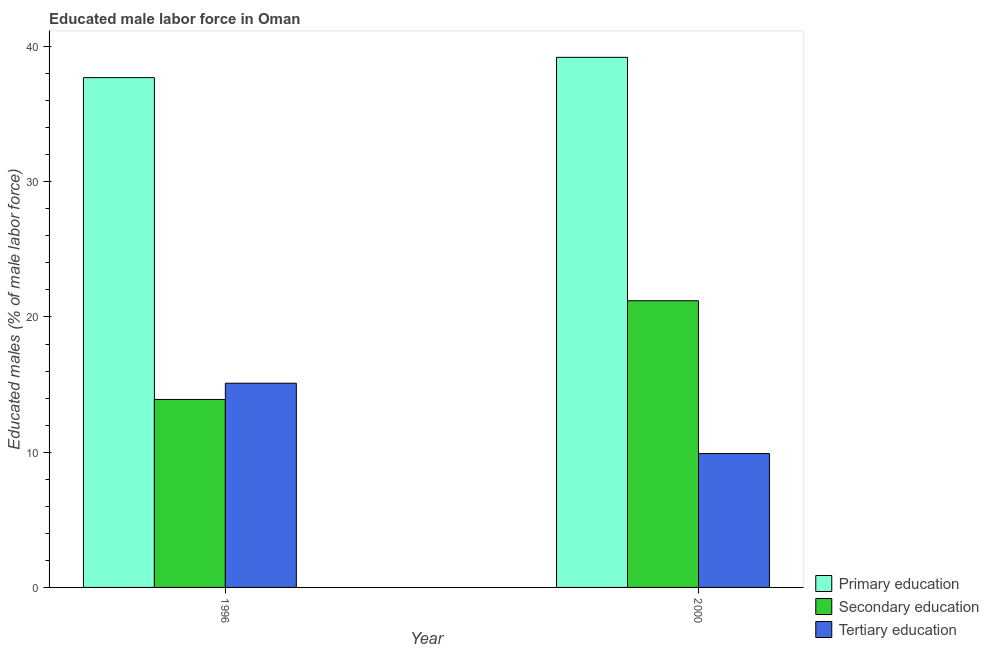How many groups of bars are there?
Your response must be concise. 2. Are the number of bars per tick equal to the number of legend labels?
Keep it short and to the point. Yes. Are the number of bars on each tick of the X-axis equal?
Your answer should be compact. Yes. How many bars are there on the 2nd tick from the left?
Provide a succinct answer. 3. How many bars are there on the 2nd tick from the right?
Your response must be concise. 3. In how many cases, is the number of bars for a given year not equal to the number of legend labels?
Offer a very short reply. 0. What is the percentage of male labor force who received secondary education in 2000?
Offer a very short reply. 21.2. Across all years, what is the maximum percentage of male labor force who received tertiary education?
Keep it short and to the point. 15.1. Across all years, what is the minimum percentage of male labor force who received primary education?
Offer a terse response. 37.7. In which year was the percentage of male labor force who received secondary education maximum?
Your response must be concise. 2000. What is the total percentage of male labor force who received primary education in the graph?
Make the answer very short. 76.9. What is the difference between the percentage of male labor force who received primary education in 1996 and that in 2000?
Keep it short and to the point. -1.5. What is the difference between the percentage of male labor force who received primary education in 2000 and the percentage of male labor force who received tertiary education in 1996?
Provide a short and direct response. 1.5. What is the average percentage of male labor force who received primary education per year?
Give a very brief answer. 38.45. What is the ratio of the percentage of male labor force who received secondary education in 1996 to that in 2000?
Offer a terse response. 0.66. Is the percentage of male labor force who received primary education in 1996 less than that in 2000?
Keep it short and to the point. Yes. In how many years, is the percentage of male labor force who received secondary education greater than the average percentage of male labor force who received secondary education taken over all years?
Your answer should be compact. 1. What does the 1st bar from the left in 2000 represents?
Your response must be concise. Primary education. What does the 1st bar from the right in 2000 represents?
Your response must be concise. Tertiary education. Is it the case that in every year, the sum of the percentage of male labor force who received primary education and percentage of male labor force who received secondary education is greater than the percentage of male labor force who received tertiary education?
Ensure brevity in your answer.  Yes. How many years are there in the graph?
Your answer should be very brief. 2. What is the difference between two consecutive major ticks on the Y-axis?
Offer a very short reply. 10. Does the graph contain grids?
Your response must be concise. No. Where does the legend appear in the graph?
Your response must be concise. Bottom right. How are the legend labels stacked?
Make the answer very short. Vertical. What is the title of the graph?
Offer a terse response. Educated male labor force in Oman. What is the label or title of the X-axis?
Offer a very short reply. Year. What is the label or title of the Y-axis?
Make the answer very short. Educated males (% of male labor force). What is the Educated males (% of male labor force) of Primary education in 1996?
Keep it short and to the point. 37.7. What is the Educated males (% of male labor force) of Secondary education in 1996?
Keep it short and to the point. 13.9. What is the Educated males (% of male labor force) of Tertiary education in 1996?
Keep it short and to the point. 15.1. What is the Educated males (% of male labor force) of Primary education in 2000?
Offer a very short reply. 39.2. What is the Educated males (% of male labor force) of Secondary education in 2000?
Give a very brief answer. 21.2. What is the Educated males (% of male labor force) of Tertiary education in 2000?
Ensure brevity in your answer.  9.9. Across all years, what is the maximum Educated males (% of male labor force) of Primary education?
Make the answer very short. 39.2. Across all years, what is the maximum Educated males (% of male labor force) of Secondary education?
Your answer should be very brief. 21.2. Across all years, what is the maximum Educated males (% of male labor force) in Tertiary education?
Your response must be concise. 15.1. Across all years, what is the minimum Educated males (% of male labor force) of Primary education?
Your response must be concise. 37.7. Across all years, what is the minimum Educated males (% of male labor force) of Secondary education?
Keep it short and to the point. 13.9. Across all years, what is the minimum Educated males (% of male labor force) in Tertiary education?
Provide a succinct answer. 9.9. What is the total Educated males (% of male labor force) in Primary education in the graph?
Provide a succinct answer. 76.9. What is the total Educated males (% of male labor force) of Secondary education in the graph?
Your answer should be compact. 35.1. What is the total Educated males (% of male labor force) of Tertiary education in the graph?
Provide a succinct answer. 25. What is the difference between the Educated males (% of male labor force) in Secondary education in 1996 and that in 2000?
Keep it short and to the point. -7.3. What is the difference between the Educated males (% of male labor force) of Tertiary education in 1996 and that in 2000?
Your response must be concise. 5.2. What is the difference between the Educated males (% of male labor force) of Primary education in 1996 and the Educated males (% of male labor force) of Secondary education in 2000?
Keep it short and to the point. 16.5. What is the difference between the Educated males (% of male labor force) of Primary education in 1996 and the Educated males (% of male labor force) of Tertiary education in 2000?
Give a very brief answer. 27.8. What is the difference between the Educated males (% of male labor force) in Secondary education in 1996 and the Educated males (% of male labor force) in Tertiary education in 2000?
Your answer should be very brief. 4. What is the average Educated males (% of male labor force) in Primary education per year?
Your answer should be compact. 38.45. What is the average Educated males (% of male labor force) of Secondary education per year?
Your answer should be compact. 17.55. In the year 1996, what is the difference between the Educated males (% of male labor force) of Primary education and Educated males (% of male labor force) of Secondary education?
Provide a short and direct response. 23.8. In the year 1996, what is the difference between the Educated males (% of male labor force) of Primary education and Educated males (% of male labor force) of Tertiary education?
Offer a very short reply. 22.6. In the year 2000, what is the difference between the Educated males (% of male labor force) of Primary education and Educated males (% of male labor force) of Secondary education?
Your response must be concise. 18. In the year 2000, what is the difference between the Educated males (% of male labor force) of Primary education and Educated males (% of male labor force) of Tertiary education?
Your answer should be compact. 29.3. In the year 2000, what is the difference between the Educated males (% of male labor force) of Secondary education and Educated males (% of male labor force) of Tertiary education?
Your response must be concise. 11.3. What is the ratio of the Educated males (% of male labor force) in Primary education in 1996 to that in 2000?
Make the answer very short. 0.96. What is the ratio of the Educated males (% of male labor force) in Secondary education in 1996 to that in 2000?
Offer a very short reply. 0.66. What is the ratio of the Educated males (% of male labor force) of Tertiary education in 1996 to that in 2000?
Give a very brief answer. 1.53. What is the difference between the highest and the second highest Educated males (% of male labor force) of Primary education?
Ensure brevity in your answer.  1.5. What is the difference between the highest and the second highest Educated males (% of male labor force) of Secondary education?
Provide a short and direct response. 7.3. What is the difference between the highest and the lowest Educated males (% of male labor force) of Primary education?
Provide a short and direct response. 1.5. 